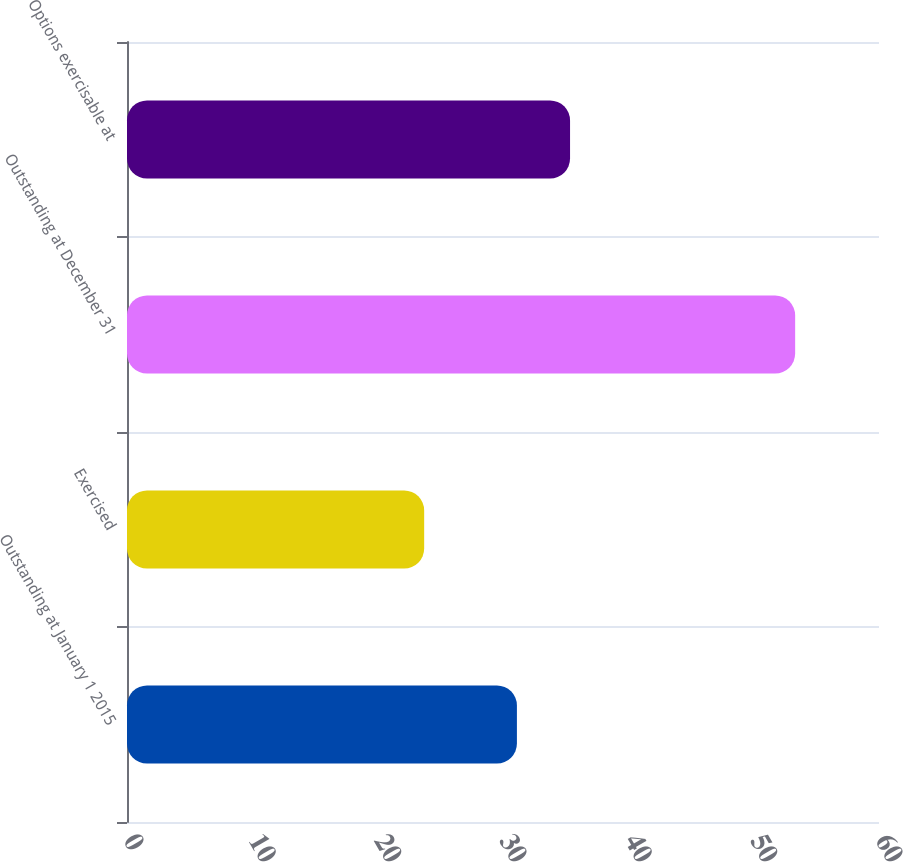Convert chart. <chart><loc_0><loc_0><loc_500><loc_500><bar_chart><fcel>Outstanding at January 1 2015<fcel>Exercised<fcel>Outstanding at December 31<fcel>Options exercisable at<nl><fcel>31.11<fcel>23.71<fcel>53.31<fcel>35.35<nl></chart> 